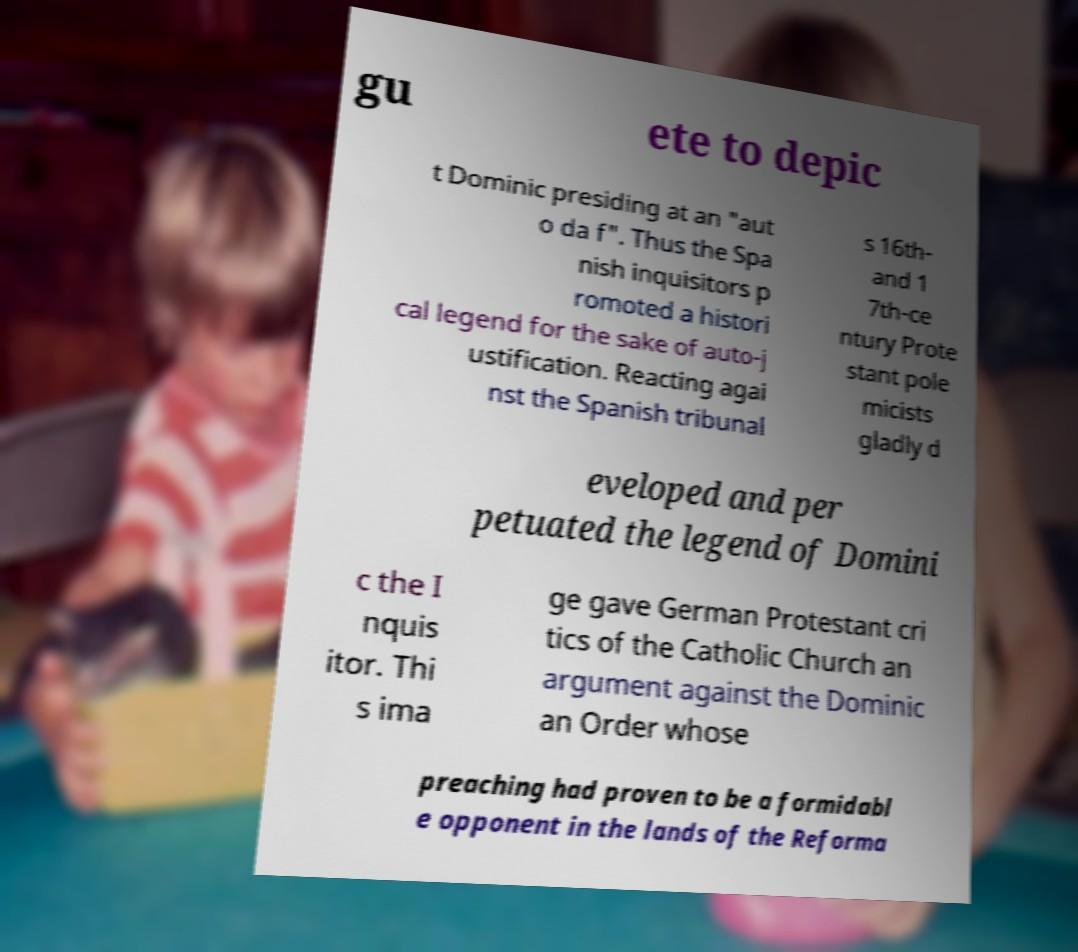Can you read and provide the text displayed in the image?This photo seems to have some interesting text. Can you extract and type it out for me? gu ete to depic t Dominic presiding at an "aut o da f". Thus the Spa nish inquisitors p romoted a histori cal legend for the sake of auto-j ustification. Reacting agai nst the Spanish tribunal s 16th- and 1 7th-ce ntury Prote stant pole micists gladly d eveloped and per petuated the legend of Domini c the I nquis itor. Thi s ima ge gave German Protestant cri tics of the Catholic Church an argument against the Dominic an Order whose preaching had proven to be a formidabl e opponent in the lands of the Reforma 